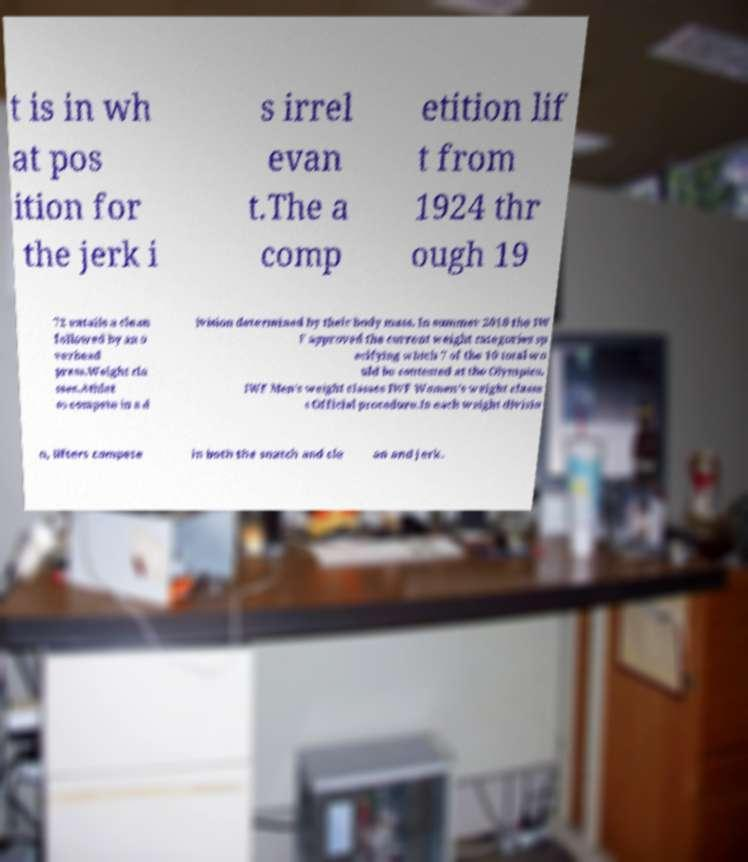What messages or text are displayed in this image? I need them in a readable, typed format. t is in wh at pos ition for the jerk i s irrel evan t.The a comp etition lif t from 1924 thr ough 19 72 entails a clean followed by an o verhead press.Weight cla sses.Athlet es compete in a d ivision determined by their body mass. In summer 2018 the IW F approved the current weight categories sp ecifying which 7 of the 10 total wo uld be contested at the Olympics. IWF Men's weight classes IWF Women's weight classe s Official procedure.In each weight divisio n, lifters compete in both the snatch and cle an and jerk. 